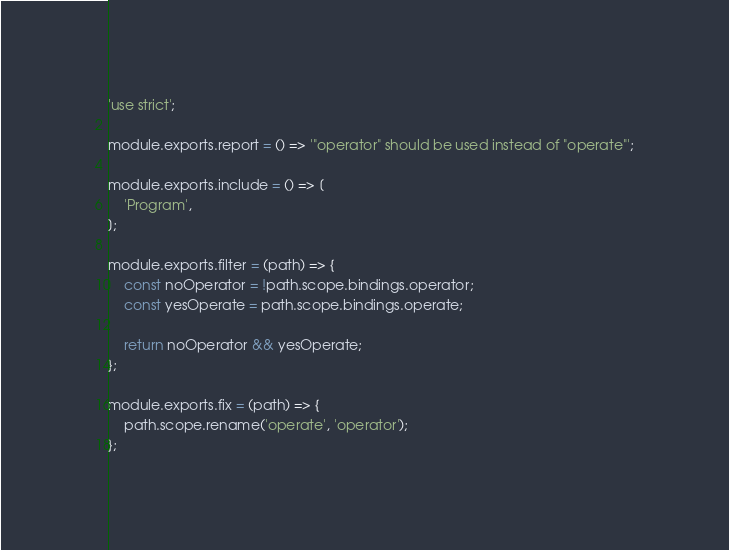Convert code to text. <code><loc_0><loc_0><loc_500><loc_500><_JavaScript_>'use strict';

module.exports.report = () => '"operator" should be used instead of "operate"';

module.exports.include = () => [
    'Program',
];

module.exports.filter = (path) => {
    const noOperator = !path.scope.bindings.operator;
    const yesOperate = path.scope.bindings.operate;
    
    return noOperator && yesOperate;
};

module.exports.fix = (path) => {
    path.scope.rename('operate', 'operator');
};
</code> 